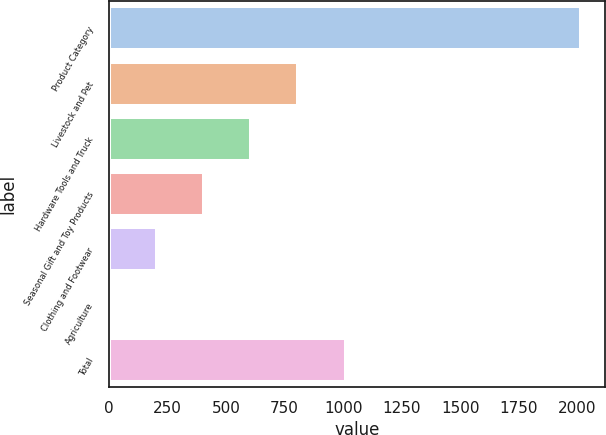<chart> <loc_0><loc_0><loc_500><loc_500><bar_chart><fcel>Product Category<fcel>Livestock and Pet<fcel>Hardware Tools and Truck<fcel>Seasonal Gift and Toy Products<fcel>Clothing and Footwear<fcel>Agriculture<fcel>Total<nl><fcel>2016<fcel>809.4<fcel>608.3<fcel>407.2<fcel>206.1<fcel>5<fcel>1010.5<nl></chart> 